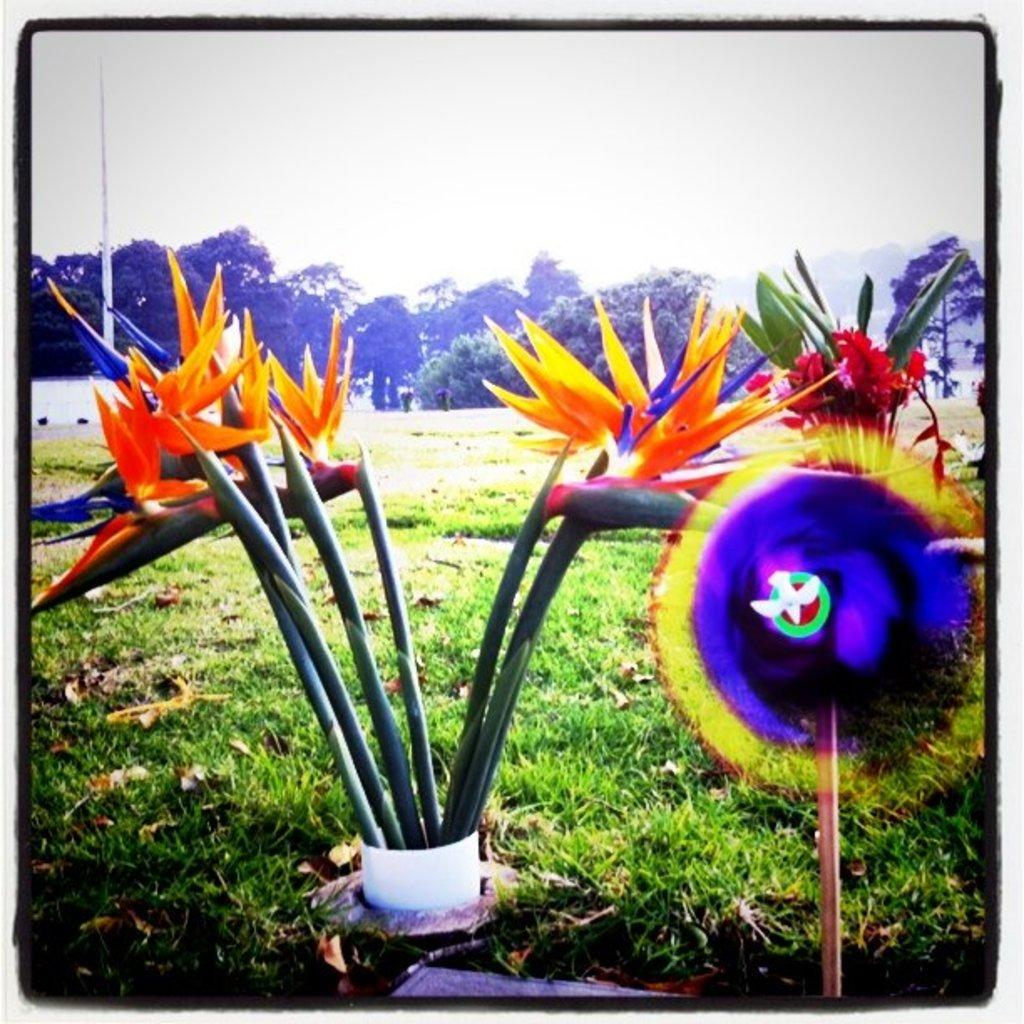What types of vegetation can be seen at the bottom of the image? There are plants, flowers, and grass at the bottom of the image. What else can be seen in the background of the image? There are trees and the sky visible in the background of the image. What type of collar can be seen on the tree in the image? There is no collar present on any tree in the image. What interest rate is being offered by the flowers in the image? There is no mention of interest rates or offers in the image; it features plants, flowers, grass, trees, and the sky. 